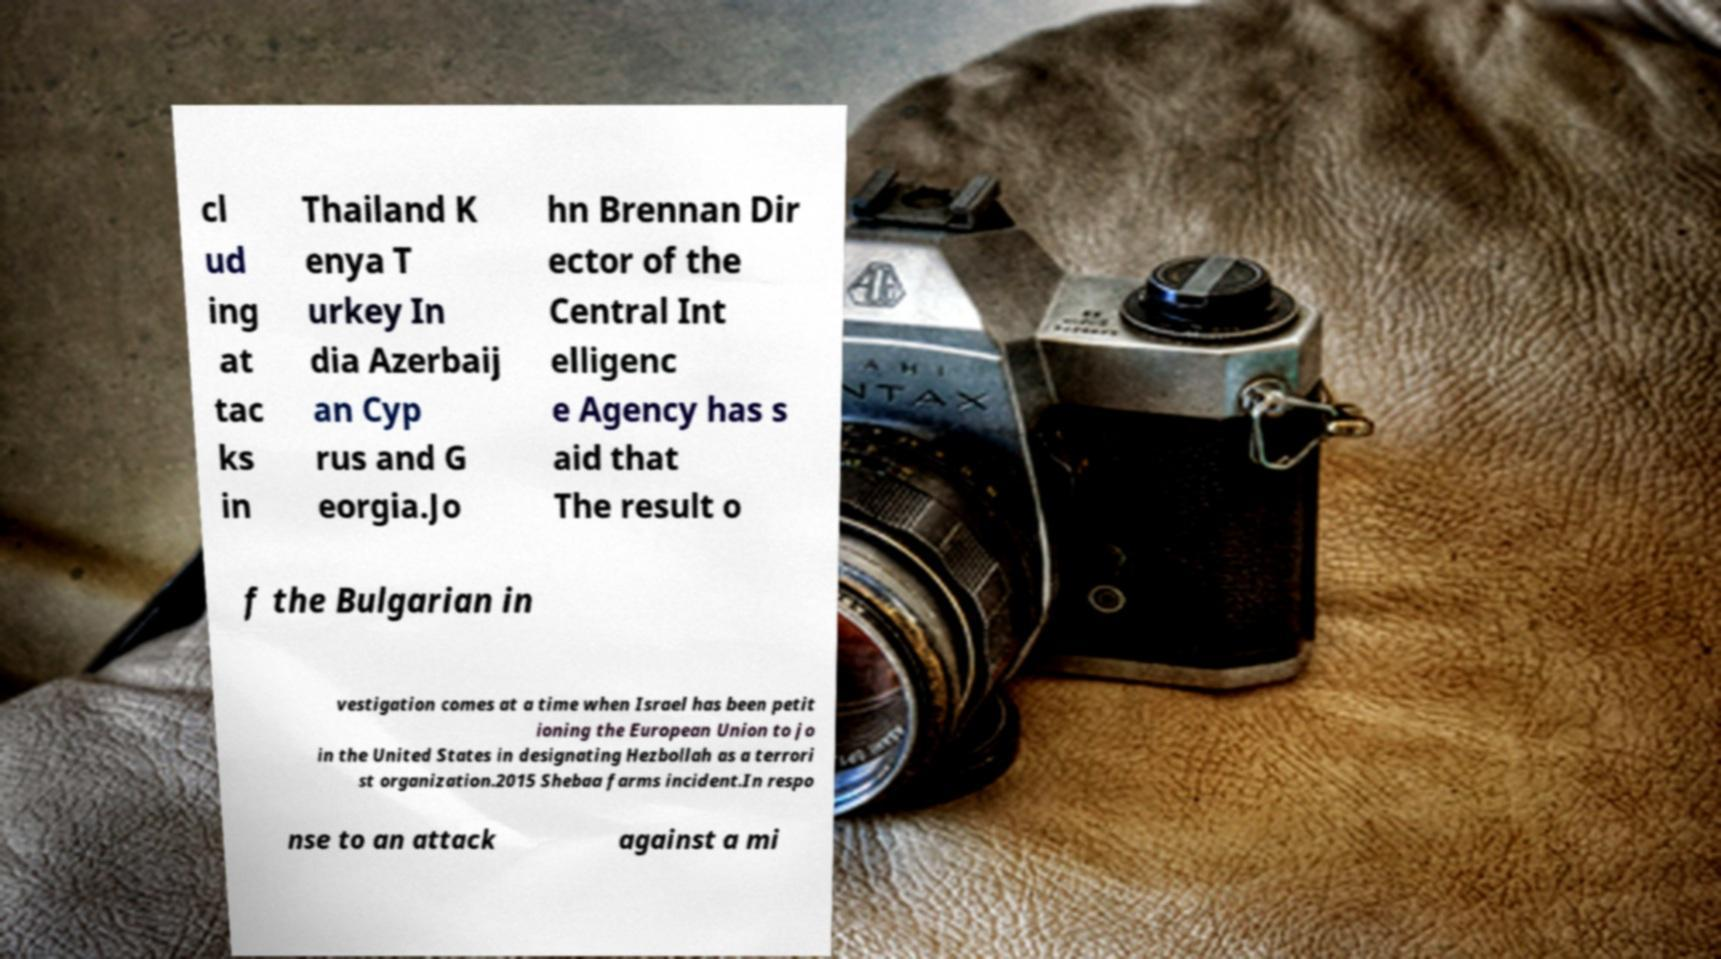For documentation purposes, I need the text within this image transcribed. Could you provide that? cl ud ing at tac ks in Thailand K enya T urkey In dia Azerbaij an Cyp rus and G eorgia.Jo hn Brennan Dir ector of the Central Int elligenc e Agency has s aid that The result o f the Bulgarian in vestigation comes at a time when Israel has been petit ioning the European Union to jo in the United States in designating Hezbollah as a terrori st organization.2015 Shebaa farms incident.In respo nse to an attack against a mi 